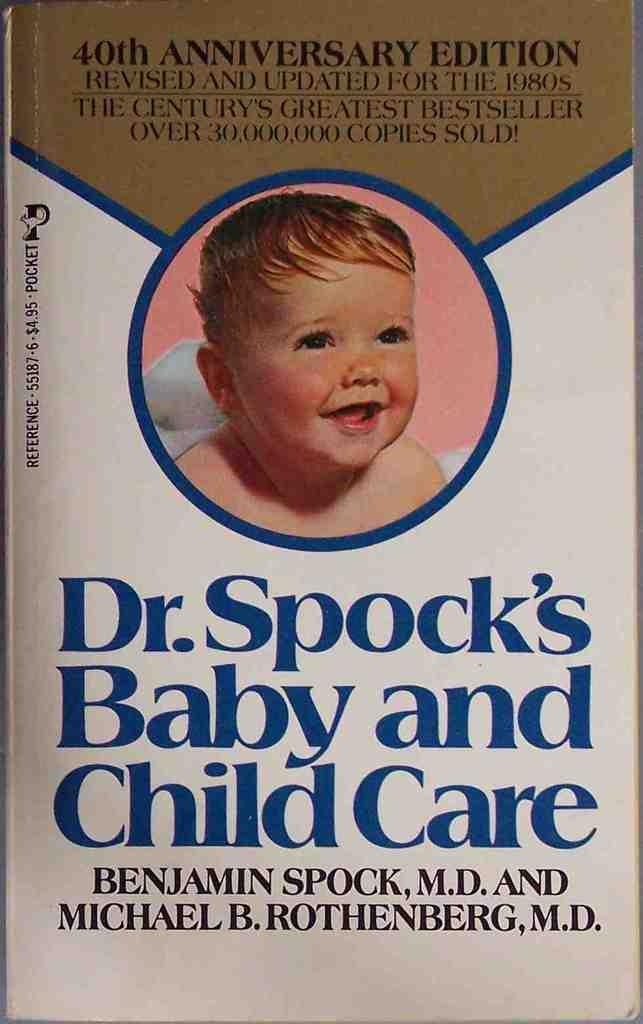What is present on the poster in the image? There is a poster in the image. What can be found on the poster besides the image of a baby? There are writings on the poster. What type of image is depicted on the poster? There is an image of a baby on the poster. What type of cars are visible in the image? There are no cars present in the image; it features a poster with an image of a baby and writings. How many thumbs can be seen on the baby's hand in the image? There is no baby's hand visible in the image, as it only shows a poster with an image of a baby and writings. 